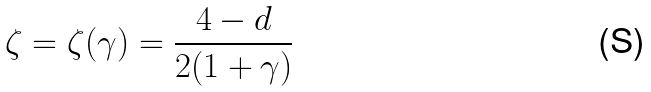Convert formula to latex. <formula><loc_0><loc_0><loc_500><loc_500>\zeta = \zeta ( \gamma ) = \frac { 4 - d } { 2 ( 1 + \gamma ) }</formula> 